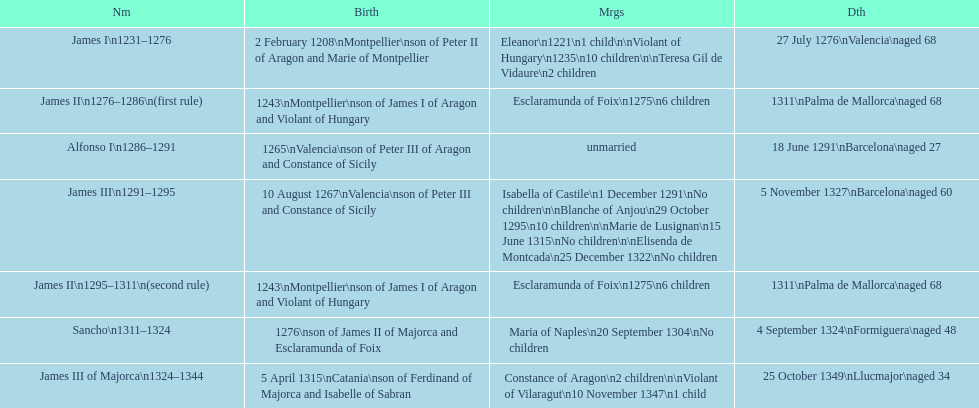How long was james ii in power, including his second rule? 26 years. 